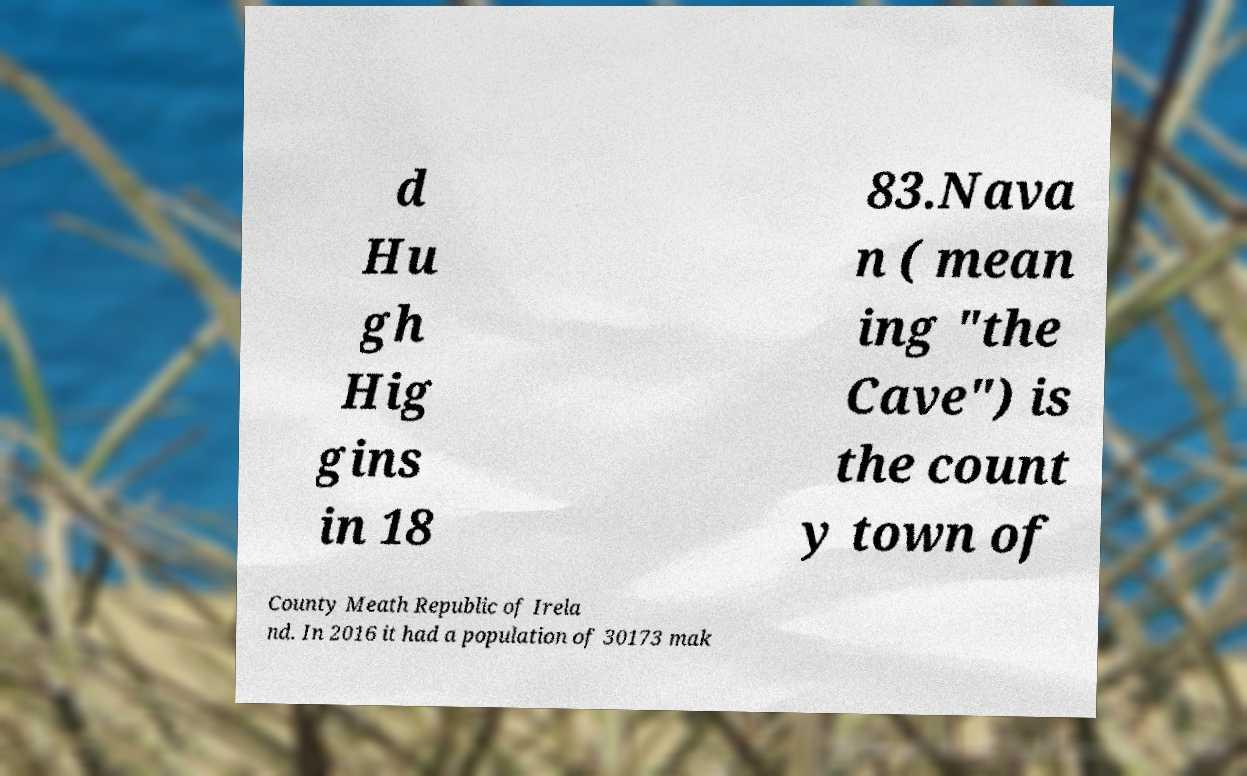Please read and relay the text visible in this image. What does it say? d Hu gh Hig gins in 18 83.Nava n ( mean ing "the Cave") is the count y town of County Meath Republic of Irela nd. In 2016 it had a population of 30173 mak 